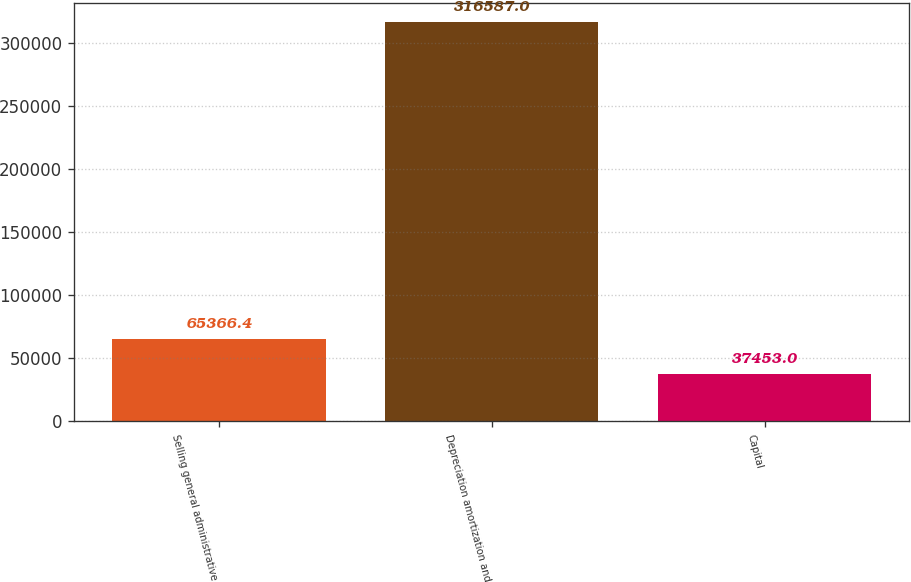Convert chart to OTSL. <chart><loc_0><loc_0><loc_500><loc_500><bar_chart><fcel>Selling general administrative<fcel>Depreciation amortization and<fcel>Capital<nl><fcel>65366.4<fcel>316587<fcel>37453<nl></chart> 